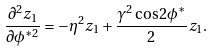Convert formula to latex. <formula><loc_0><loc_0><loc_500><loc_500>\frac { \partial ^ { 2 } z _ { 1 } } { \partial \phi ^ { * 2 } } = - \eta ^ { 2 } z _ { 1 } + \frac { \gamma ^ { 2 } \cos 2 \phi ^ { * } } { 2 } z _ { 1 } .</formula> 